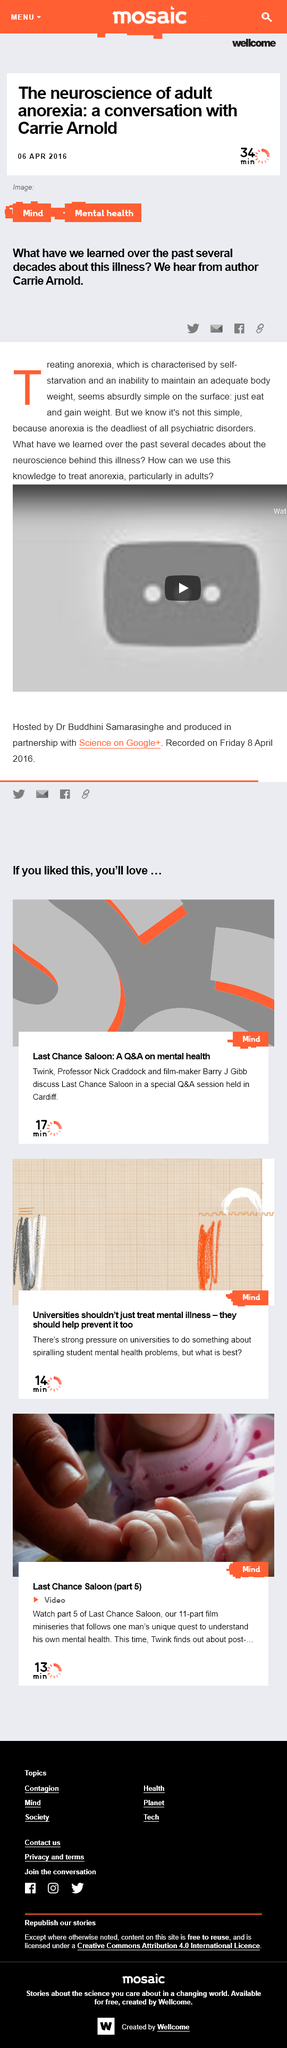Point out several critical features in this image. It takes approximately thirty-four minutes to read this article. Carrie Arnold writes about an illness known as anorexia. 